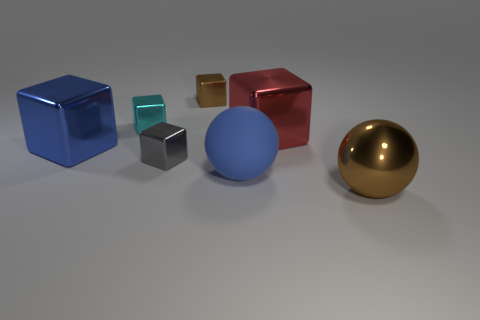What size is the metallic cube that is both in front of the large red thing and on the right side of the tiny cyan thing?
Give a very brief answer. Small. Do the brown sphere and the matte thing that is in front of the red cube have the same size?
Give a very brief answer. Yes. Does the brown block have the same material as the blue sphere?
Give a very brief answer. No. What number of other objects are there of the same size as the gray block?
Keep it short and to the point. 2. How many other objects are the same shape as the tiny brown object?
Your response must be concise. 4. What material is the blue ball that is the same size as the red metallic cube?
Your answer should be compact. Rubber. What is the color of the big metallic cube that is right of the big blue thing that is to the right of the thing behind the small cyan metallic thing?
Give a very brief answer. Red. There is a blue object to the right of the brown shiny block; is it the same shape as the brown object that is in front of the tiny gray thing?
Provide a succinct answer. Yes. How many blue cubes are there?
Your answer should be compact. 1. There is a metallic ball that is the same size as the blue cube; what color is it?
Your answer should be very brief. Brown. 